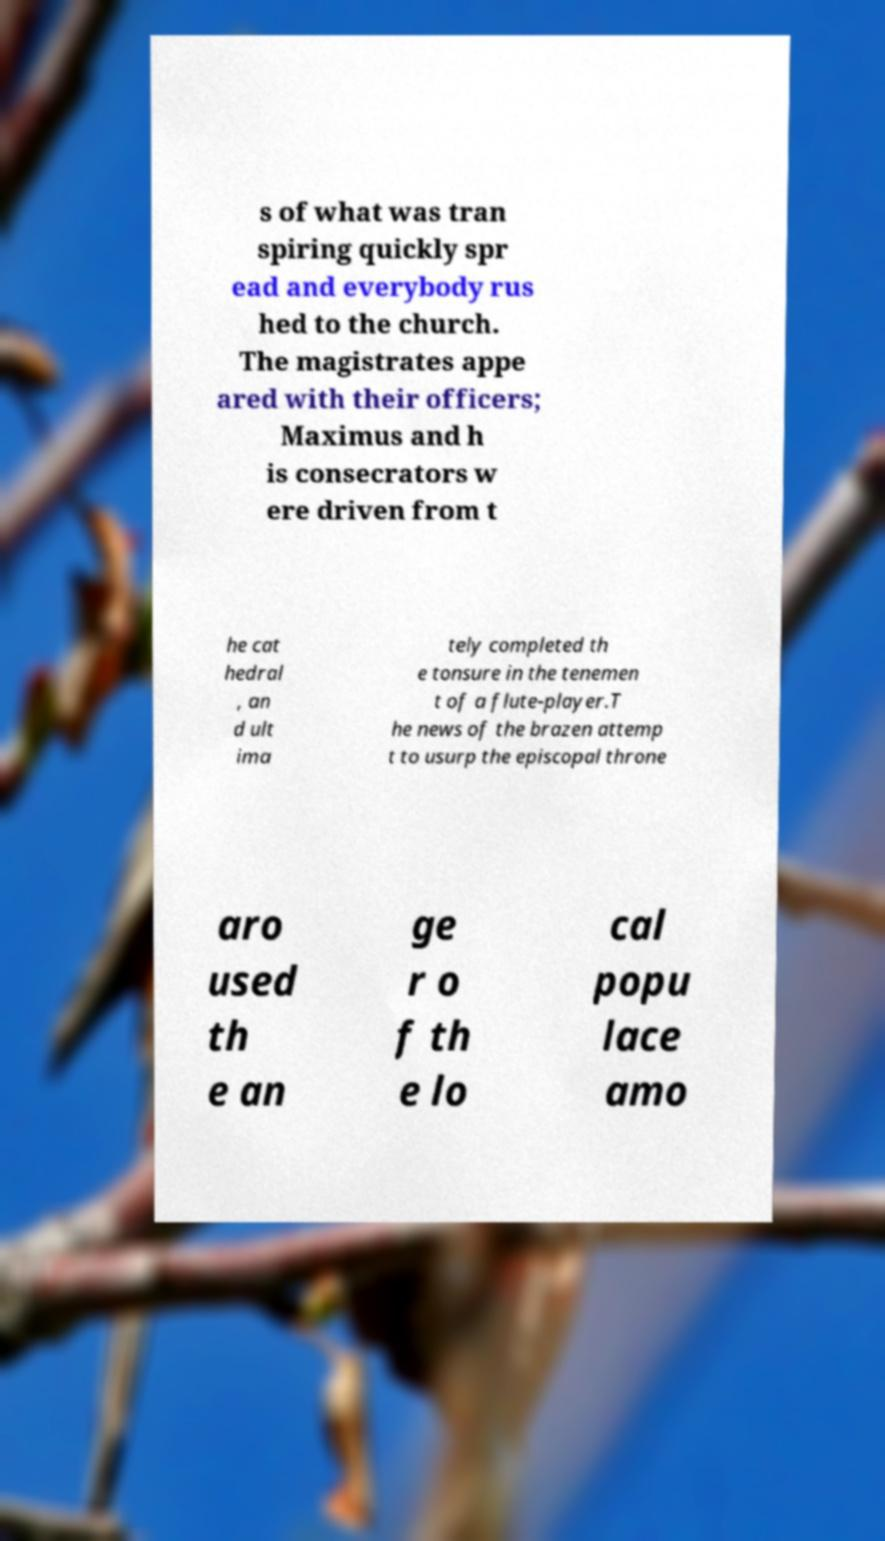Could you assist in decoding the text presented in this image and type it out clearly? s of what was tran spiring quickly spr ead and everybody rus hed to the church. The magistrates appe ared with their officers; Maximus and h is consecrators w ere driven from t he cat hedral , an d ult ima tely completed th e tonsure in the tenemen t of a flute-player.T he news of the brazen attemp t to usurp the episcopal throne aro used th e an ge r o f th e lo cal popu lace amo 